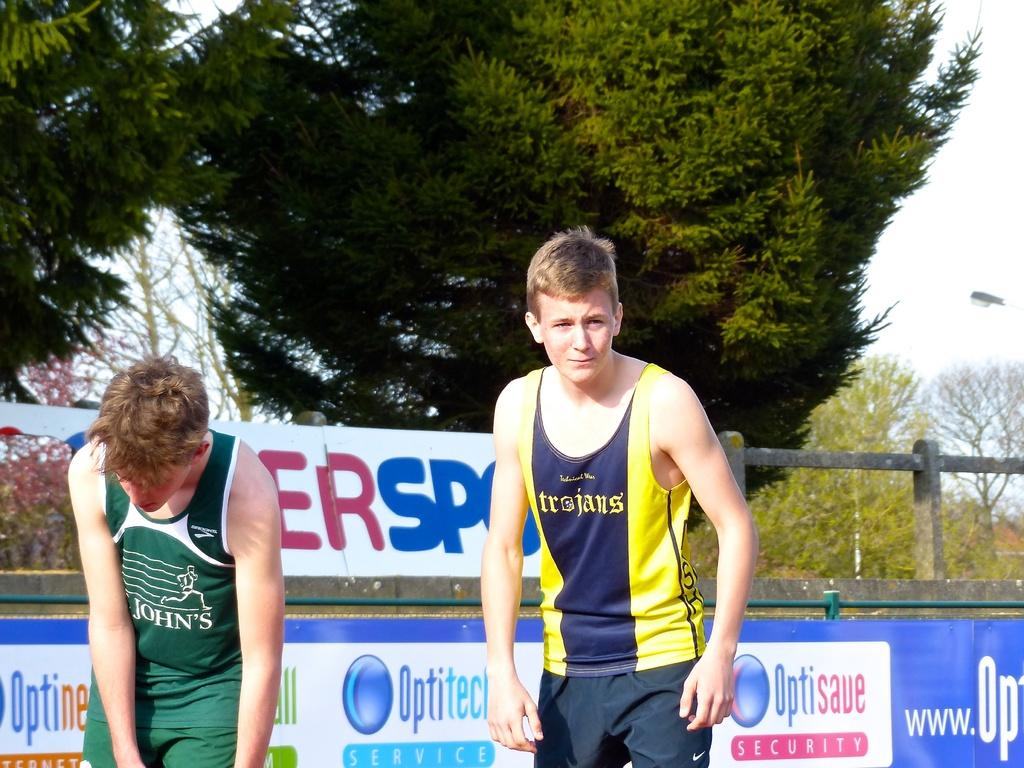How many people are in the image? There are two boys standing in the image. What can be seen hanging in the image? There are banners in the image. What type of barrier is present in the image? There is a fence in the image. What type of vegetation is visible in the image? There are trees in the image. What is visible in the background of the image? The sky is visible in the background of the image. What type of lettuce is growing on the fence in the image? There is no lettuce present in the image; it features two boys, banners, a fence, trees, and the sky. 